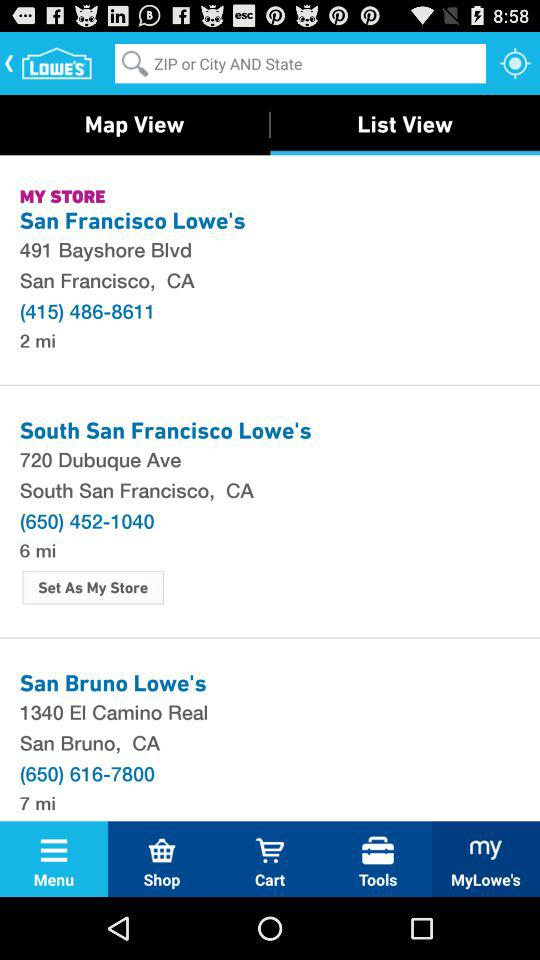What is the contact number for San Francisco Lowe's? The contact number is (415) 486-8611. 